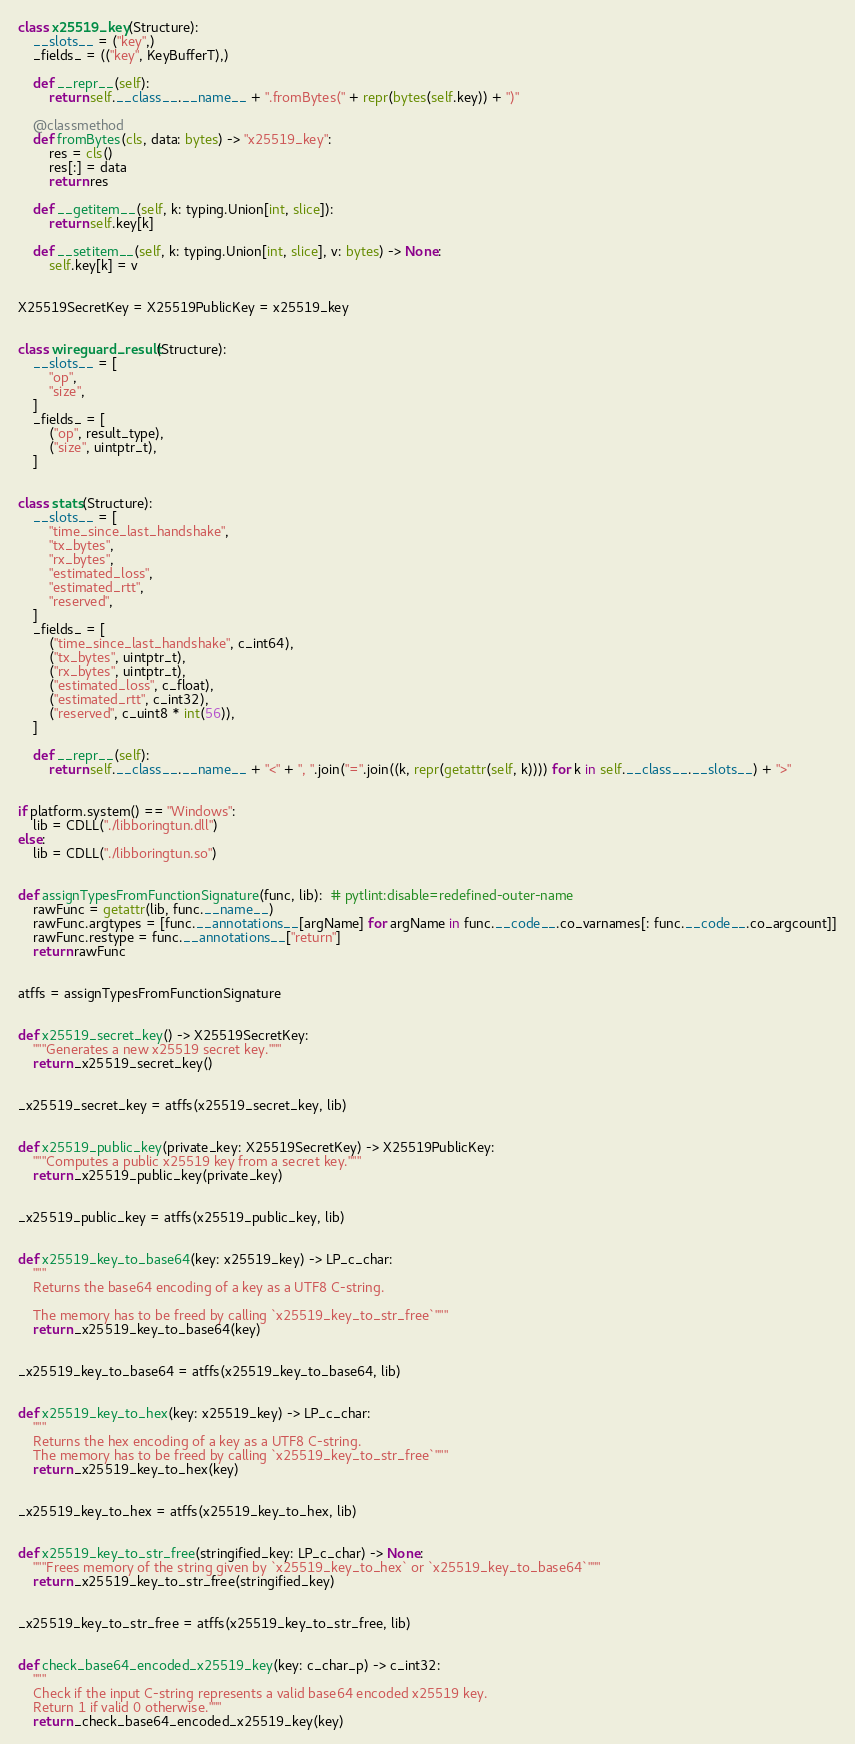<code> <loc_0><loc_0><loc_500><loc_500><_Python_>

class x25519_key(Structure):
	__slots__ = ("key",)
	_fields_ = (("key", KeyBufferT),)

	def __repr__(self):
		return self.__class__.__name__ + ".fromBytes(" + repr(bytes(self.key)) + ")"

	@classmethod
	def fromBytes(cls, data: bytes) -> "x25519_key":
		res = cls()
		res[:] = data
		return res

	def __getitem__(self, k: typing.Union[int, slice]):
		return self.key[k]

	def __setitem__(self, k: typing.Union[int, slice], v: bytes) -> None:
		self.key[k] = v


X25519SecretKey = X25519PublicKey = x25519_key


class wireguard_result(Structure):
	__slots__ = [
		"op",
		"size",
	]
	_fields_ = [
		("op", result_type),
		("size", uintptr_t),
	]


class stats(Structure):
	__slots__ = [
		"time_since_last_handshake",
		"tx_bytes",
		"rx_bytes",
		"estimated_loss",
		"estimated_rtt",
		"reserved",
	]
	_fields_ = [
		("time_since_last_handshake", c_int64),
		("tx_bytes", uintptr_t),
		("rx_bytes", uintptr_t),
		("estimated_loss", c_float),
		("estimated_rtt", c_int32),
		("reserved", c_uint8 * int(56)),
	]

	def __repr__(self):
		return self.__class__.__name__ + "<" + ", ".join("=".join((k, repr(getattr(self, k)))) for k in self.__class__.__slots__) + ">"


if platform.system() == "Windows":
	lib = CDLL("./libboringtun.dll")
else:
	lib = CDLL("./libboringtun.so")


def assignTypesFromFunctionSignature(func, lib):  # pytlint:disable=redefined-outer-name
	rawFunc = getattr(lib, func.__name__)
	rawFunc.argtypes = [func.__annotations__[argName] for argName in func.__code__.co_varnames[: func.__code__.co_argcount]]
	rawFunc.restype = func.__annotations__["return"]
	return rawFunc


atffs = assignTypesFromFunctionSignature


def x25519_secret_key() -> X25519SecretKey:
	"""Generates a new x25519 secret key."""
	return _x25519_secret_key()


_x25519_secret_key = atffs(x25519_secret_key, lib)


def x25519_public_key(private_key: X25519SecretKey) -> X25519PublicKey:
	"""Computes a public x25519 key from a secret key."""
	return _x25519_public_key(private_key)


_x25519_public_key = atffs(x25519_public_key, lib)


def x25519_key_to_base64(key: x25519_key) -> LP_c_char:
	"""
	Returns the base64 encoding of a key as a UTF8 C-string.

	The memory has to be freed by calling `x25519_key_to_str_free`"""
	return _x25519_key_to_base64(key)


_x25519_key_to_base64 = atffs(x25519_key_to_base64, lib)


def x25519_key_to_hex(key: x25519_key) -> LP_c_char:
	"""
	Returns the hex encoding of a key as a UTF8 C-string.
	The memory has to be freed by calling `x25519_key_to_str_free`"""
	return _x25519_key_to_hex(key)


_x25519_key_to_hex = atffs(x25519_key_to_hex, lib)


def x25519_key_to_str_free(stringified_key: LP_c_char) -> None:
	"""Frees memory of the string given by `x25519_key_to_hex` or `x25519_key_to_base64`"""
	return _x25519_key_to_str_free(stringified_key)


_x25519_key_to_str_free = atffs(x25519_key_to_str_free, lib)


def check_base64_encoded_x25519_key(key: c_char_p) -> c_int32:
	"""
	Check if the input C-string represents a valid base64 encoded x25519 key.
	Return 1 if valid 0 otherwise."""
	return _check_base64_encoded_x25519_key(key)

</code> 